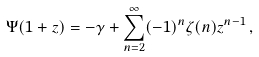<formula> <loc_0><loc_0><loc_500><loc_500>\Psi ( 1 + z ) = - \gamma + \sum _ { n = 2 } ^ { \infty } ( - 1 ) ^ { n } \zeta ( n ) z ^ { n - 1 } \, ,</formula> 